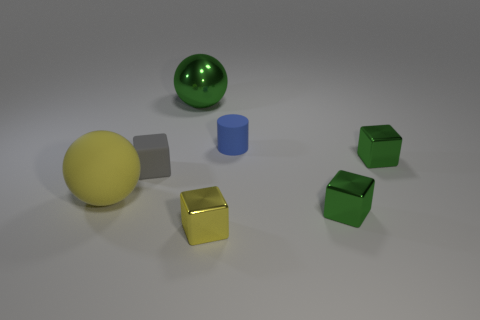Subtract all yellow cubes. How many cubes are left? 3 Subtract all gray cylinders. How many green cubes are left? 2 Subtract all gray blocks. How many blocks are left? 3 Subtract 2 blocks. How many blocks are left? 2 Add 2 blue cubes. How many objects exist? 9 Subtract all cylinders. How many objects are left? 6 Subtract all yellow metal cylinders. Subtract all gray blocks. How many objects are left? 6 Add 6 gray blocks. How many gray blocks are left? 7 Add 5 tiny green metal cubes. How many tiny green metal cubes exist? 7 Subtract 0 cyan spheres. How many objects are left? 7 